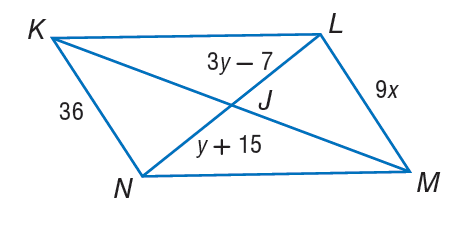Answer the mathemtical geometry problem and directly provide the correct option letter.
Question: If K L M N is a parallelogram, fnd x.
Choices: A: 4 B: 5 C: 12 D: 26 A 